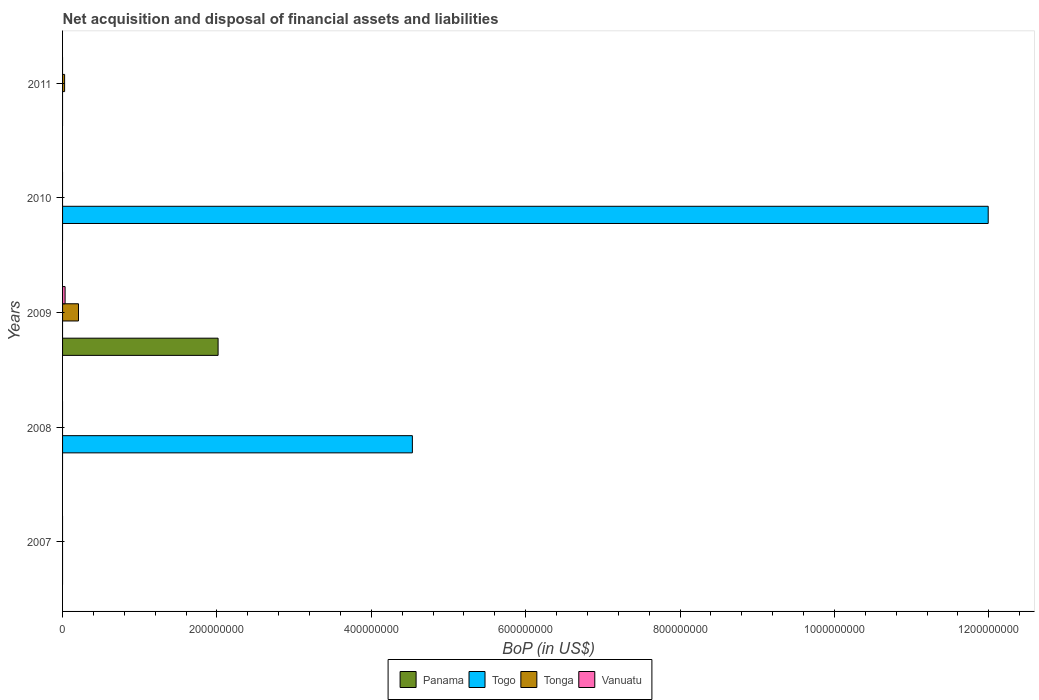How many different coloured bars are there?
Your answer should be compact. 4. Are the number of bars on each tick of the Y-axis equal?
Your answer should be very brief. No. What is the label of the 3rd group of bars from the top?
Your response must be concise. 2009. What is the Balance of Payments in Panama in 2011?
Your answer should be very brief. 0. Across all years, what is the maximum Balance of Payments in Panama?
Your answer should be compact. 2.02e+08. What is the total Balance of Payments in Panama in the graph?
Your response must be concise. 2.02e+08. What is the difference between the Balance of Payments in Togo in 2008 and that in 2010?
Offer a very short reply. -7.46e+08. What is the difference between the Balance of Payments in Tonga in 2009 and the Balance of Payments in Panama in 2011?
Give a very brief answer. 2.06e+07. What is the average Balance of Payments in Togo per year?
Provide a short and direct response. 3.30e+08. In the year 2009, what is the difference between the Balance of Payments in Panama and Balance of Payments in Vanuatu?
Give a very brief answer. 1.98e+08. What is the difference between the highest and the lowest Balance of Payments in Vanuatu?
Offer a very short reply. 3.27e+06. In how many years, is the Balance of Payments in Togo greater than the average Balance of Payments in Togo taken over all years?
Ensure brevity in your answer.  2. Is it the case that in every year, the sum of the Balance of Payments in Panama and Balance of Payments in Vanuatu is greater than the Balance of Payments in Togo?
Your answer should be very brief. No. Are all the bars in the graph horizontal?
Your response must be concise. Yes. Where does the legend appear in the graph?
Offer a very short reply. Bottom center. How many legend labels are there?
Keep it short and to the point. 4. What is the title of the graph?
Keep it short and to the point. Net acquisition and disposal of financial assets and liabilities. What is the label or title of the X-axis?
Provide a short and direct response. BoP (in US$). What is the label or title of the Y-axis?
Ensure brevity in your answer.  Years. What is the BoP (in US$) in Panama in 2008?
Offer a terse response. 0. What is the BoP (in US$) of Togo in 2008?
Offer a terse response. 4.53e+08. What is the BoP (in US$) of Tonga in 2008?
Your answer should be compact. 0. What is the BoP (in US$) in Panama in 2009?
Offer a very short reply. 2.02e+08. What is the BoP (in US$) of Tonga in 2009?
Provide a short and direct response. 2.06e+07. What is the BoP (in US$) in Vanuatu in 2009?
Ensure brevity in your answer.  3.27e+06. What is the BoP (in US$) of Panama in 2010?
Make the answer very short. 0. What is the BoP (in US$) of Togo in 2010?
Your answer should be very brief. 1.20e+09. What is the BoP (in US$) in Tonga in 2010?
Make the answer very short. 0. What is the BoP (in US$) in Vanuatu in 2010?
Your answer should be compact. 0. What is the BoP (in US$) in Panama in 2011?
Ensure brevity in your answer.  0. What is the BoP (in US$) in Tonga in 2011?
Your answer should be compact. 2.64e+06. Across all years, what is the maximum BoP (in US$) in Panama?
Your answer should be very brief. 2.02e+08. Across all years, what is the maximum BoP (in US$) in Togo?
Offer a terse response. 1.20e+09. Across all years, what is the maximum BoP (in US$) of Tonga?
Provide a succinct answer. 2.06e+07. Across all years, what is the maximum BoP (in US$) in Vanuatu?
Provide a short and direct response. 3.27e+06. Across all years, what is the minimum BoP (in US$) in Panama?
Keep it short and to the point. 0. Across all years, what is the minimum BoP (in US$) of Togo?
Ensure brevity in your answer.  0. Across all years, what is the minimum BoP (in US$) of Tonga?
Your response must be concise. 0. Across all years, what is the minimum BoP (in US$) in Vanuatu?
Offer a very short reply. 0. What is the total BoP (in US$) in Panama in the graph?
Your response must be concise. 2.02e+08. What is the total BoP (in US$) in Togo in the graph?
Ensure brevity in your answer.  1.65e+09. What is the total BoP (in US$) in Tonga in the graph?
Give a very brief answer. 2.33e+07. What is the total BoP (in US$) of Vanuatu in the graph?
Ensure brevity in your answer.  3.27e+06. What is the difference between the BoP (in US$) of Togo in 2008 and that in 2010?
Provide a succinct answer. -7.46e+08. What is the difference between the BoP (in US$) of Tonga in 2009 and that in 2011?
Your response must be concise. 1.80e+07. What is the difference between the BoP (in US$) in Togo in 2008 and the BoP (in US$) in Tonga in 2009?
Keep it short and to the point. 4.33e+08. What is the difference between the BoP (in US$) of Togo in 2008 and the BoP (in US$) of Vanuatu in 2009?
Provide a short and direct response. 4.50e+08. What is the difference between the BoP (in US$) of Togo in 2008 and the BoP (in US$) of Tonga in 2011?
Give a very brief answer. 4.51e+08. What is the difference between the BoP (in US$) in Panama in 2009 and the BoP (in US$) in Togo in 2010?
Give a very brief answer. -9.98e+08. What is the difference between the BoP (in US$) in Panama in 2009 and the BoP (in US$) in Tonga in 2011?
Offer a terse response. 1.99e+08. What is the difference between the BoP (in US$) in Togo in 2010 and the BoP (in US$) in Tonga in 2011?
Ensure brevity in your answer.  1.20e+09. What is the average BoP (in US$) of Panama per year?
Offer a terse response. 4.03e+07. What is the average BoP (in US$) in Togo per year?
Your answer should be very brief. 3.30e+08. What is the average BoP (in US$) in Tonga per year?
Keep it short and to the point. 4.65e+06. What is the average BoP (in US$) of Vanuatu per year?
Offer a very short reply. 6.54e+05. In the year 2009, what is the difference between the BoP (in US$) in Panama and BoP (in US$) in Tonga?
Your response must be concise. 1.81e+08. In the year 2009, what is the difference between the BoP (in US$) in Panama and BoP (in US$) in Vanuatu?
Keep it short and to the point. 1.98e+08. In the year 2009, what is the difference between the BoP (in US$) in Tonga and BoP (in US$) in Vanuatu?
Give a very brief answer. 1.73e+07. What is the ratio of the BoP (in US$) of Togo in 2008 to that in 2010?
Give a very brief answer. 0.38. What is the ratio of the BoP (in US$) of Tonga in 2009 to that in 2011?
Offer a terse response. 7.81. What is the difference between the highest and the lowest BoP (in US$) in Panama?
Give a very brief answer. 2.02e+08. What is the difference between the highest and the lowest BoP (in US$) in Togo?
Keep it short and to the point. 1.20e+09. What is the difference between the highest and the lowest BoP (in US$) of Tonga?
Keep it short and to the point. 2.06e+07. What is the difference between the highest and the lowest BoP (in US$) in Vanuatu?
Give a very brief answer. 3.27e+06. 